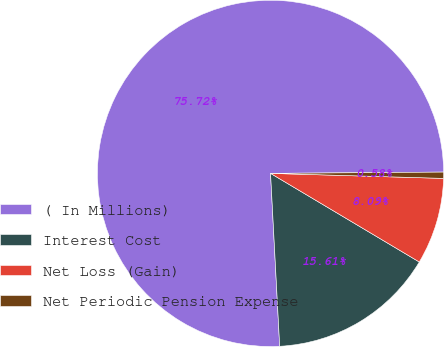Convert chart to OTSL. <chart><loc_0><loc_0><loc_500><loc_500><pie_chart><fcel>( In Millions)<fcel>Interest Cost<fcel>Net Loss (Gain)<fcel>Net Periodic Pension Expense<nl><fcel>75.73%<fcel>15.61%<fcel>8.09%<fcel>0.58%<nl></chart> 